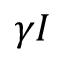<formula> <loc_0><loc_0><loc_500><loc_500>\gamma I</formula> 